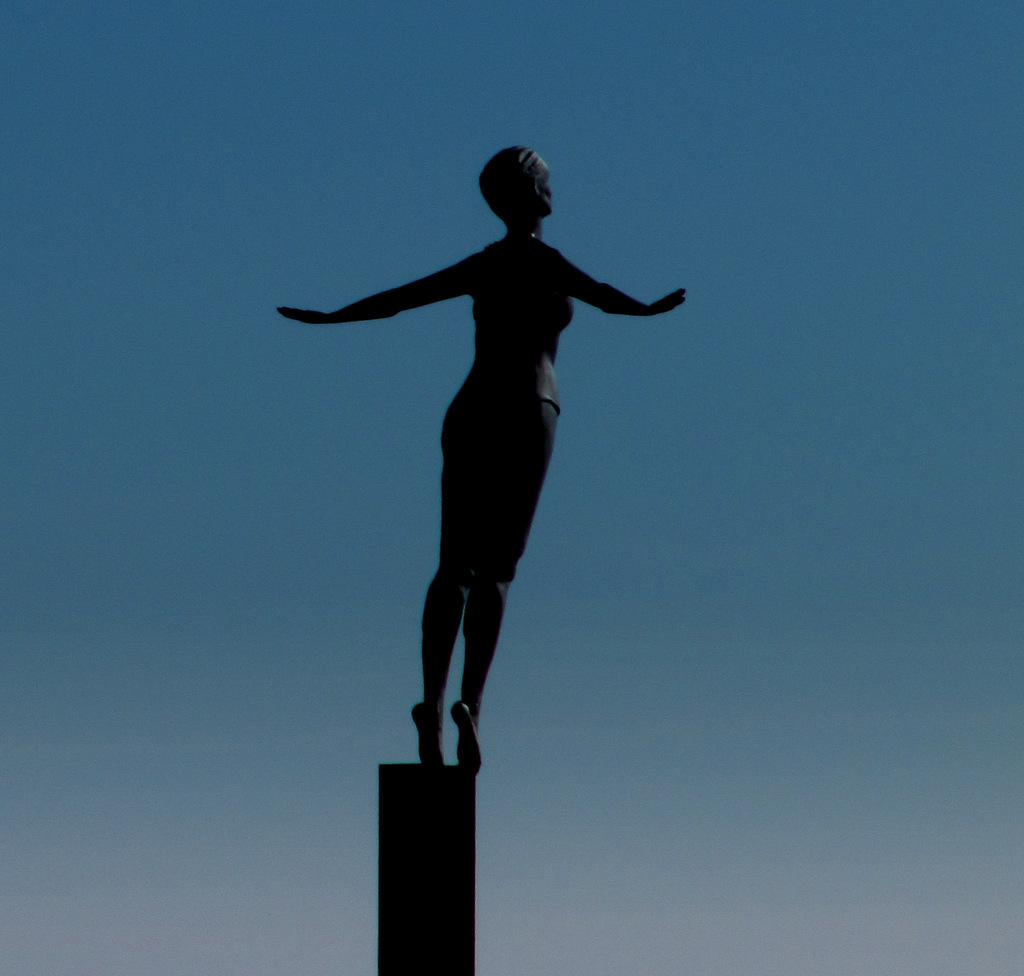What is the main subject of the image? The main subject of the image is a sculpture of a person. What can be seen in the background of the image? The sky is visible in the image. What type of feather can be seen in the image? There is no feather present in the image. Is there a nest visible in the image? No, there is no nest visible in the image. 